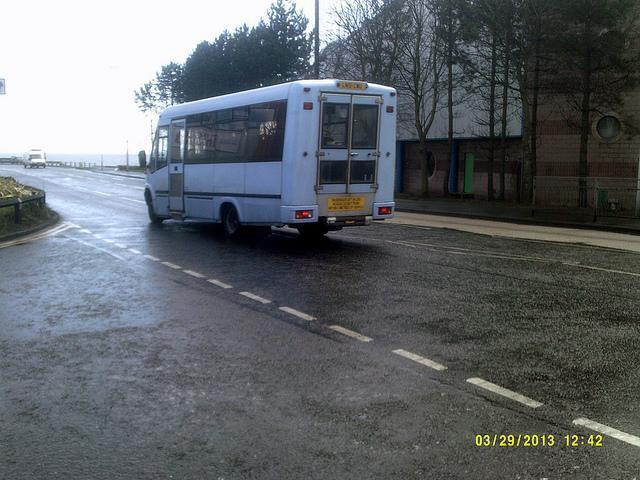How many knives are on the wall?
Give a very brief answer. 0. 